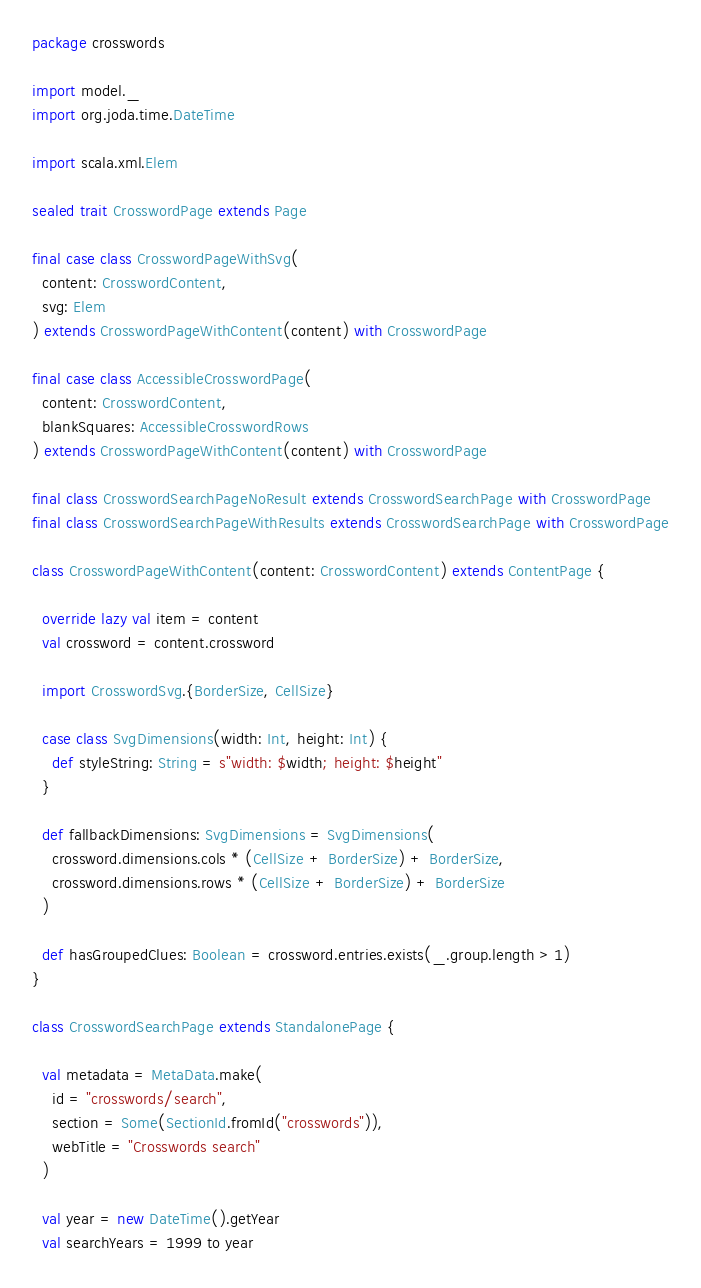<code> <loc_0><loc_0><loc_500><loc_500><_Scala_>package crosswords

import model._
import org.joda.time.DateTime

import scala.xml.Elem

sealed trait CrosswordPage extends Page

final case class CrosswordPageWithSvg(
  content: CrosswordContent,
  svg: Elem
) extends CrosswordPageWithContent(content) with CrosswordPage

final case class AccessibleCrosswordPage(
  content: CrosswordContent,
  blankSquares: AccessibleCrosswordRows
) extends CrosswordPageWithContent(content) with CrosswordPage

final class CrosswordSearchPageNoResult extends CrosswordSearchPage with CrosswordPage
final class CrosswordSearchPageWithResults extends CrosswordSearchPage with CrosswordPage

class CrosswordPageWithContent(content: CrosswordContent) extends ContentPage {

  override lazy val item = content
  val crossword = content.crossword

  import CrosswordSvg.{BorderSize, CellSize}

  case class SvgDimensions(width: Int, height: Int) {
    def styleString: String = s"width: $width; height: $height"
  }

  def fallbackDimensions: SvgDimensions = SvgDimensions(
    crossword.dimensions.cols * (CellSize + BorderSize) + BorderSize,
    crossword.dimensions.rows * (CellSize + BorderSize) + BorderSize
  )

  def hasGroupedClues: Boolean = crossword.entries.exists(_.group.length > 1)
}

class CrosswordSearchPage extends StandalonePage {

  val metadata = MetaData.make(
    id = "crosswords/search",
    section = Some(SectionId.fromId("crosswords")),
    webTitle = "Crosswords search"
  )

  val year = new DateTime().getYear
  val searchYears = 1999 to year
</code> 